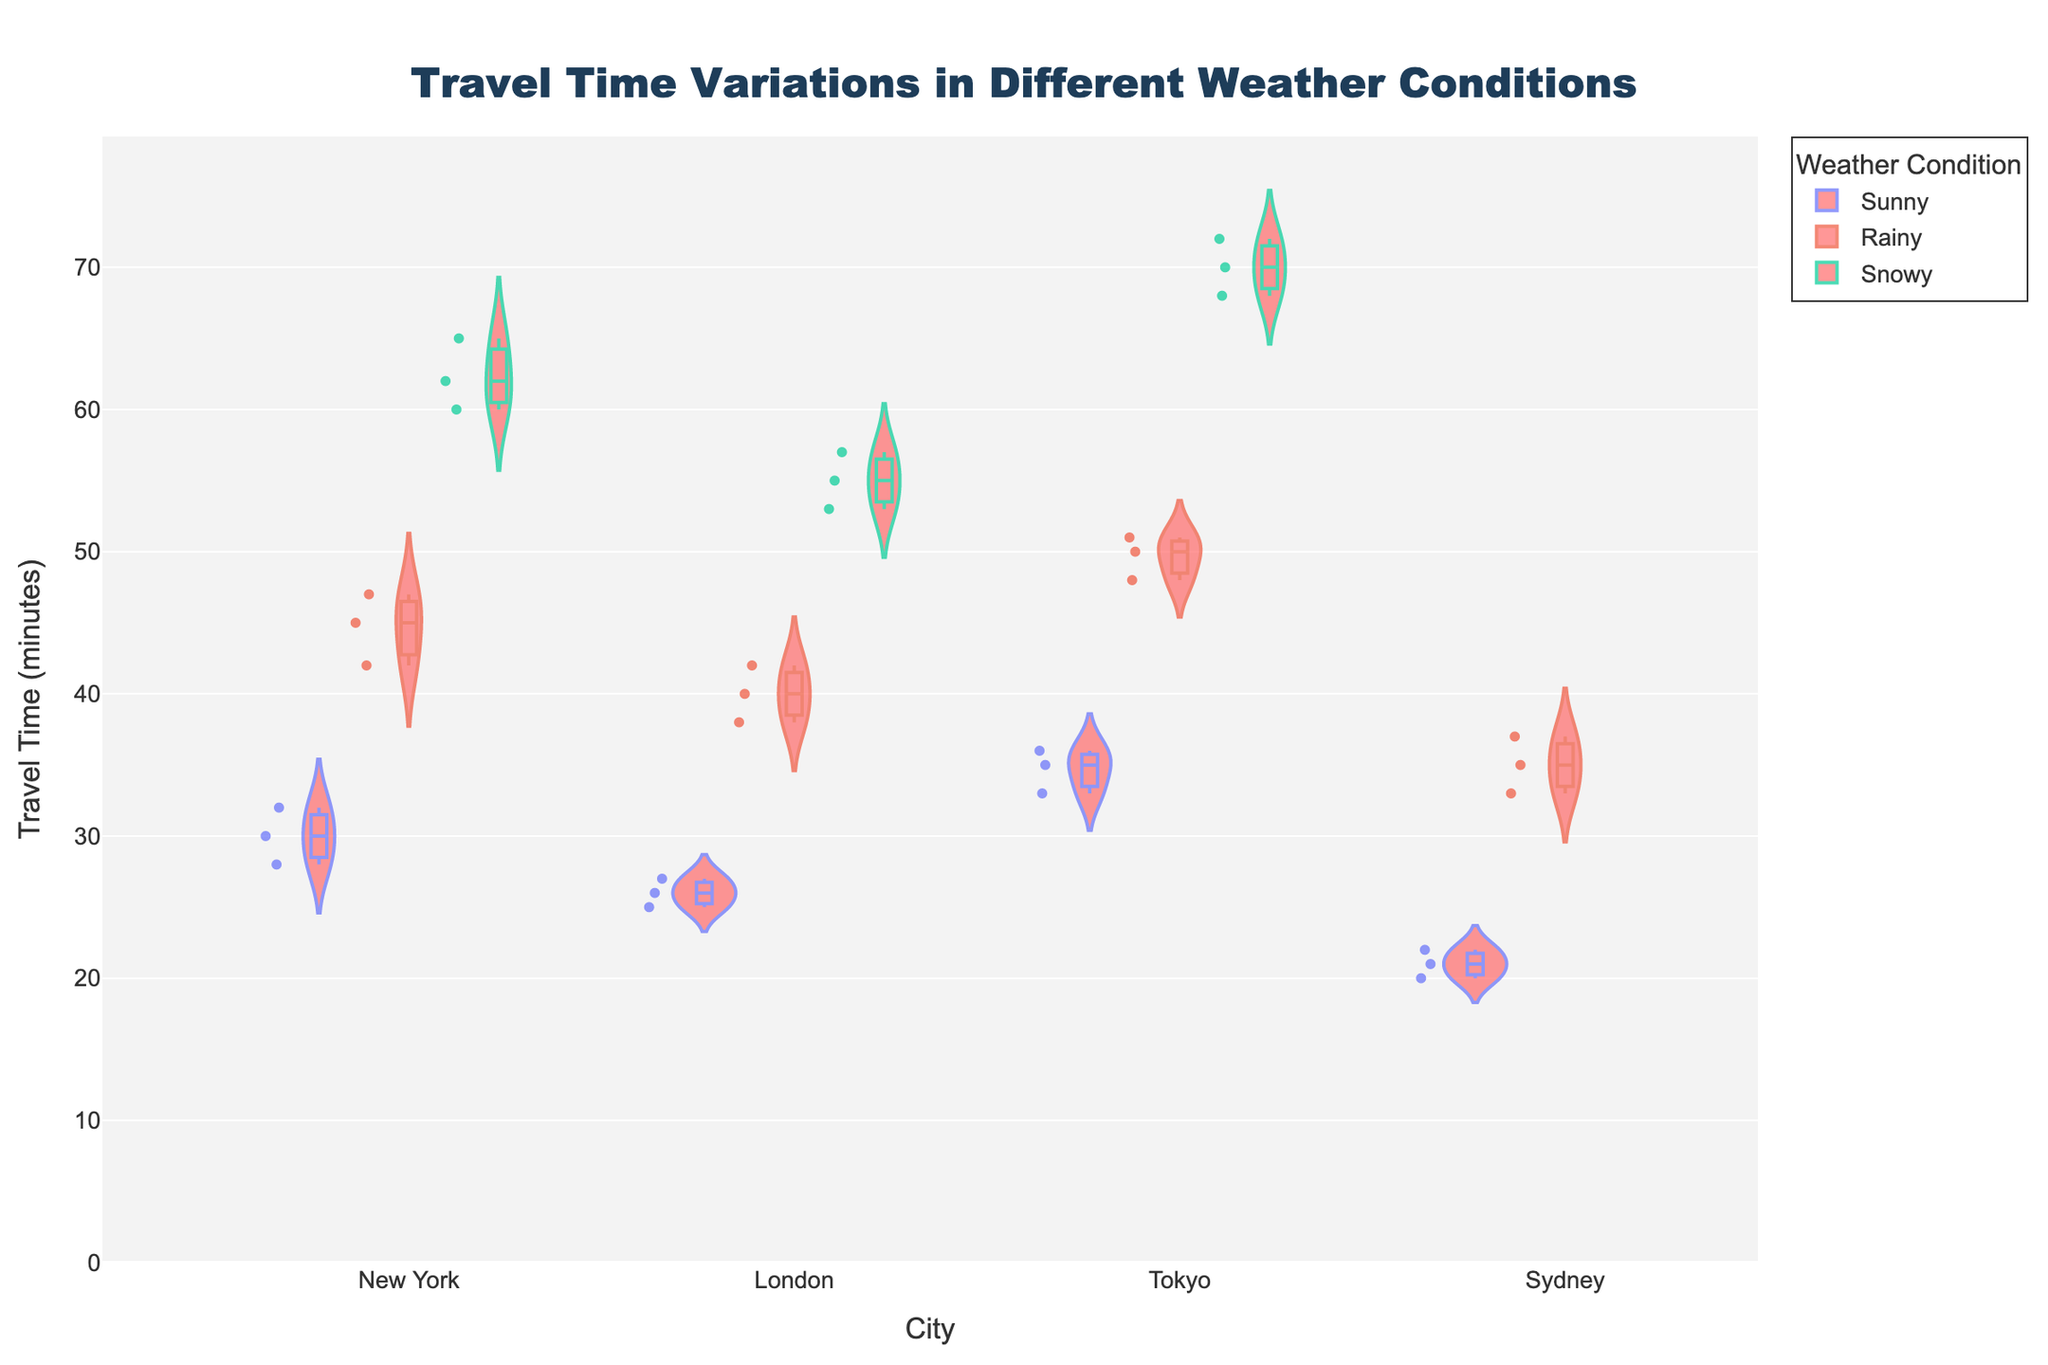Which city has the highest average travel time during snowy weather? By examining the distribution of travel times for snowy weather across cities, Tokyo has the highest average travel time as indicated by the range 68-72, compared to other cities.
Answer: Tokyo What is the title of the figure? The title is placed prominently at the top center of the display.
Answer: Travel Time Variations in Different Weather Conditions How many weather conditions are represented in the figure? The legend and color differentiation in the figure indicate three weather conditions as well as the scatter points distribution.
Answer: Three What is the range of travel times in New York during rainy weather? The violin shape illustrating New York's travel times during rainy weather ranges from 42 to 47 minutes.
Answer: 42-47 minutes Compare the median travel time of Tokyo during sunny weather with Sydney during sunny weather. Which is lower? The median is represented by a horizontal line inside each violin plot. Tokyo's sunny weather median is around 35 minutes, while Sydney's is around 21 minutes.
Answer: Sydney What insight can you gain by observing the distribution of travel times in London during different weather conditions? The distributions show that London's travel times increase with worse weather conditions: sunny (~25-27 mins), rainy (~38-42 mins), and snowy (~53-57 mins), indicating adverse weather significantly impacts travel time.
Answer: Travel times increase with worse weather Is there any city that does not have travel time data for snowy weather? By observing the snowy weather sections of the violin plots, Sydney shows no data points, implying an absence of relevant data.
Answer: Sydney Which weather condition witnesses the highest variability in travel times in New York? Observing the spread and width of the violin plots, snowy weather in New York has the widest distribution, indicating the highest variability (60-65 minutes).
Answer: Snowy Identify the city with the smallest travel time range under sunny weather conditions. The violin plot for sunny weather shows that Sydney has the smallest range of travel times (20-22 minutes), compared to other cities.
Answer: Sydney Do travel times generally increase or decrease in snowy weather across all observed cities? By examining the position and spread of the violin plots across cities, snowy weather travel times are generally higher than sunny and rainy conditions in all cities.
Answer: Increase 